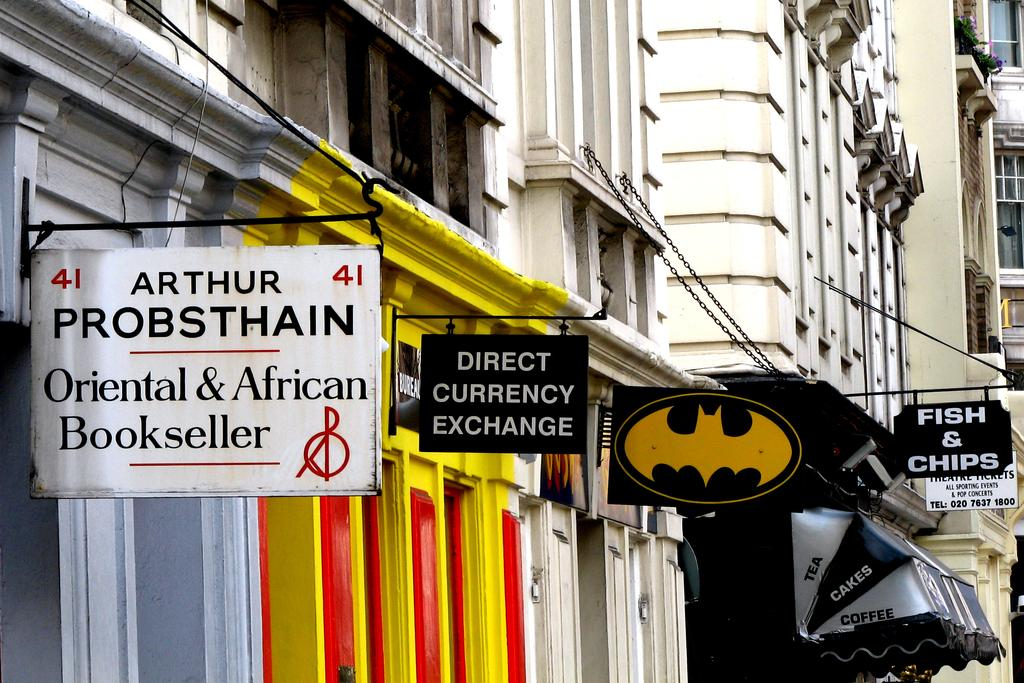What type of structures can be seen in the image? There are buildings in the image. What is located in the center of the image? There are boards in the center of the image. What type of leather is used to make the station in the image? There is no station or leather present in the image. What type of vase can be seen on the left side of the image? There is no vase present in the image. 